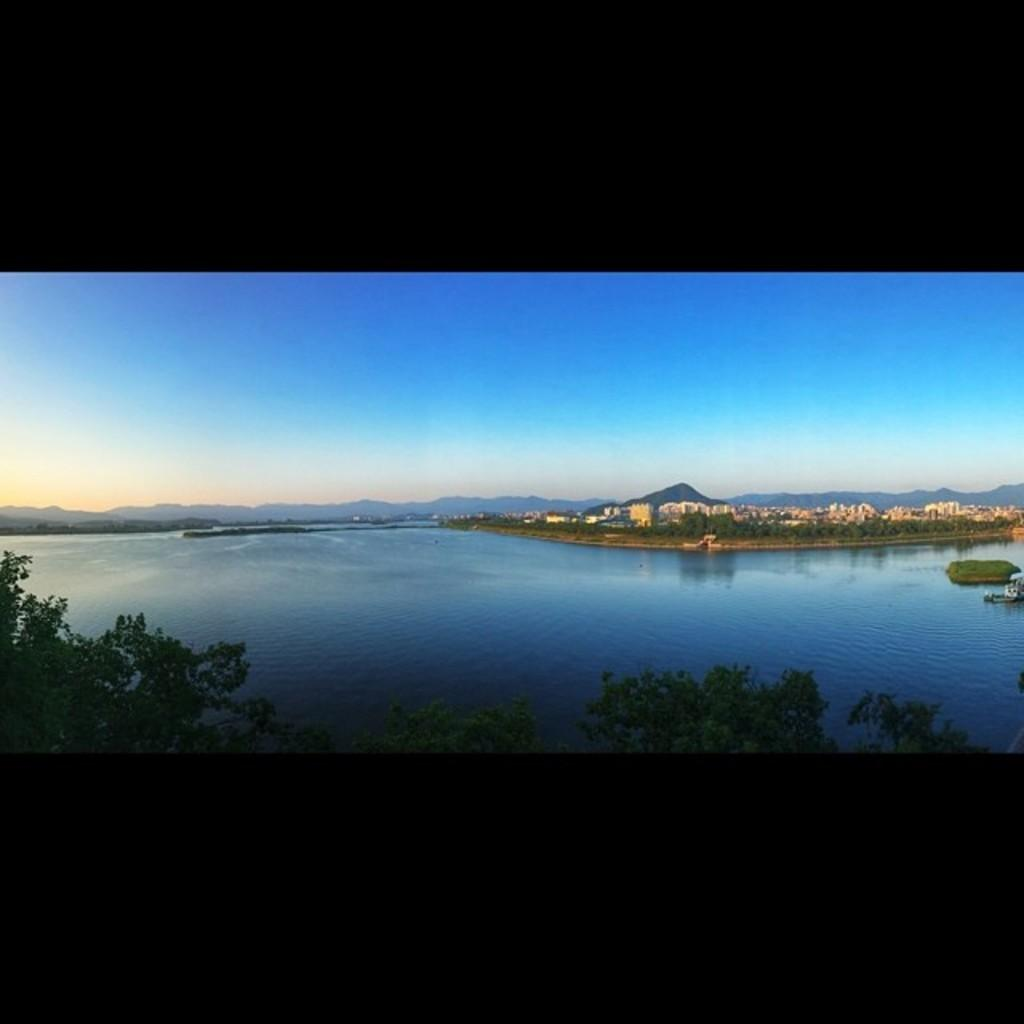What type of natural vegetation can be seen in the image? There are trees in the image. What body of water is visible in the image? There is water visible in the image. What type of man-made structures are present in the image? There are buildings in the image. What geographical feature can be seen in the distance? There are mountains in the image. What is visible in the background of the image? The sky is visible in the background of the image. What type of fuel is being used by the tail in the image? There is no tail present in the image, so it is not possible to determine what type of fuel might be used. 